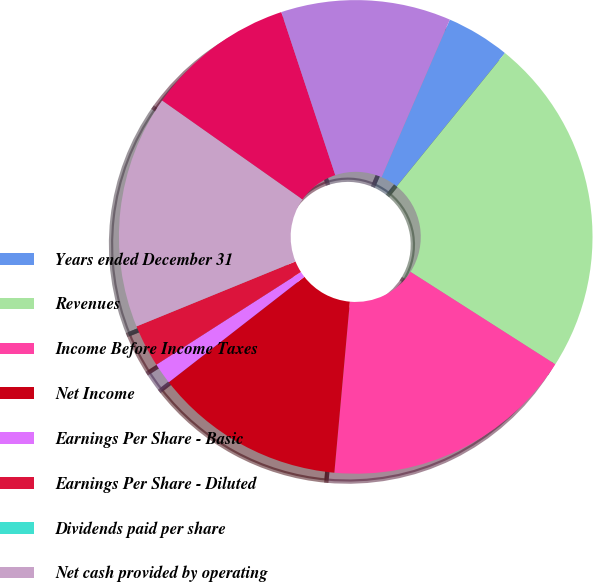Convert chart. <chart><loc_0><loc_0><loc_500><loc_500><pie_chart><fcel>Years ended December 31<fcel>Revenues<fcel>Income Before Income Taxes<fcel>Net Income<fcel>Earnings Per Share - Basic<fcel>Earnings Per Share - Diluted<fcel>Dividends paid per share<fcel>Net cash provided by operating<fcel>Net cash used in investing<fcel>Net cash used in financing<nl><fcel>4.35%<fcel>23.19%<fcel>17.39%<fcel>13.04%<fcel>1.45%<fcel>2.9%<fcel>0.0%<fcel>15.94%<fcel>10.14%<fcel>11.59%<nl></chart> 